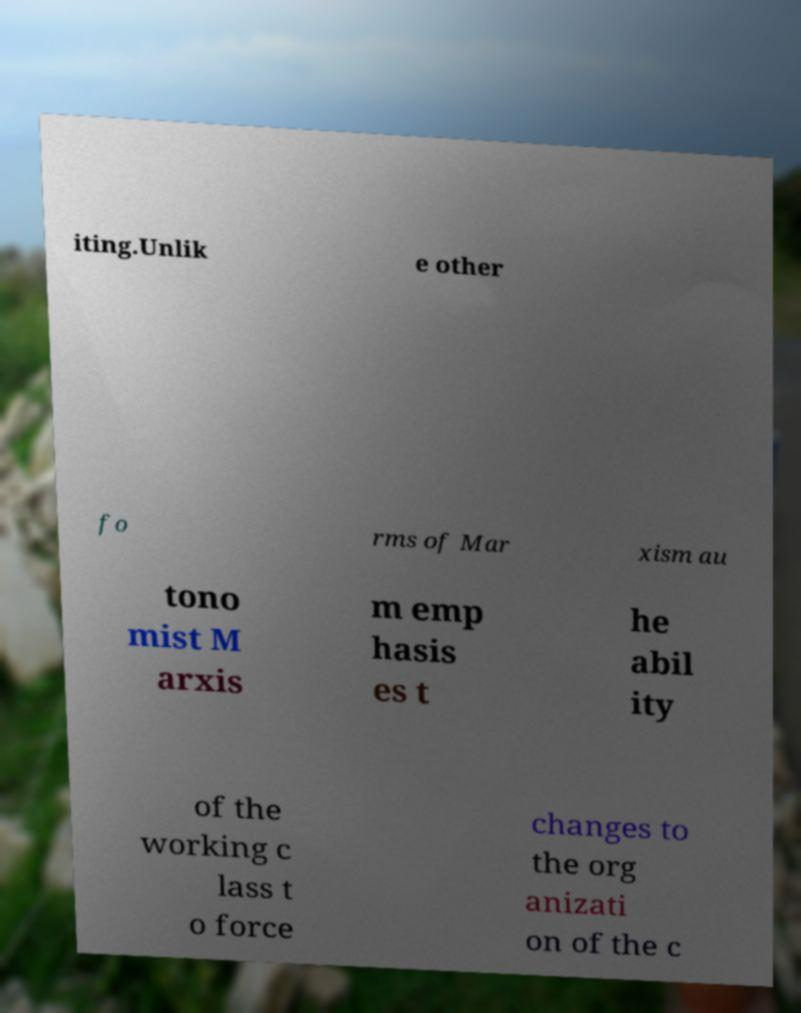Can you read and provide the text displayed in the image?This photo seems to have some interesting text. Can you extract and type it out for me? iting.Unlik e other fo rms of Mar xism au tono mist M arxis m emp hasis es t he abil ity of the working c lass t o force changes to the org anizati on of the c 